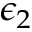Convert formula to latex. <formula><loc_0><loc_0><loc_500><loc_500>\epsilon _ { 2 }</formula> 